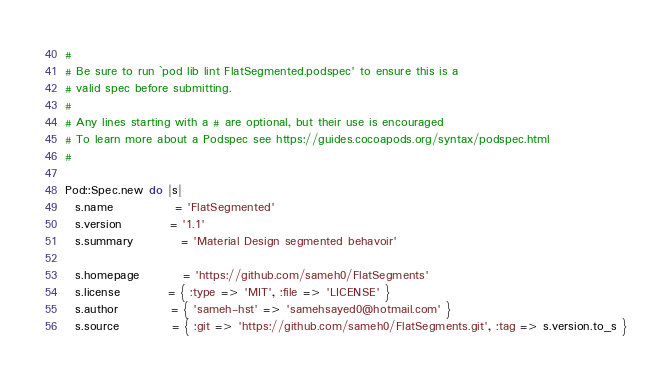Convert code to text. <code><loc_0><loc_0><loc_500><loc_500><_Ruby_>#
# Be sure to run `pod lib lint FlatSegmented.podspec' to ensure this is a
# valid spec before submitting.
#
# Any lines starting with a # are optional, but their use is encouraged
# To learn more about a Podspec see https://guides.cocoapods.org/syntax/podspec.html
#

Pod::Spec.new do |s|
  s.name             = 'FlatSegmented'
  s.version          = '1.1'
  s.summary          = 'Material Design segmented behavoir'

  s.homepage         = 'https://github.com/sameh0/FlatSegments'
  s.license          = { :type => 'MIT', :file => 'LICENSE' }
  s.author           = { 'sameh-hst' => 'samehsayed0@hotmail.com' }
  s.source           = { :git => 'https://github.com/sameh0/FlatSegments.git', :tag => s.version.to_s }</code> 